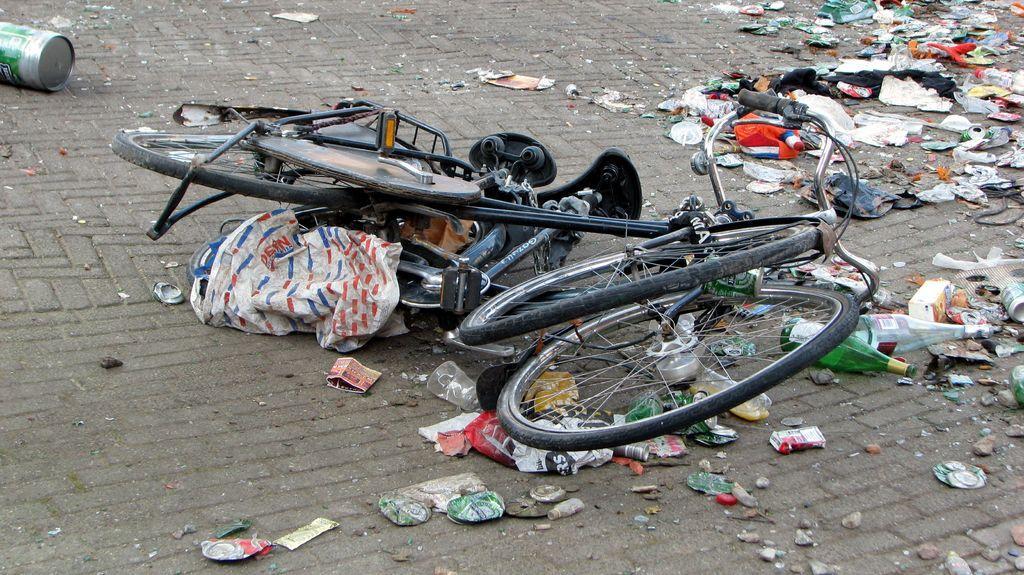Please provide a concise description of this image. In this image we can see a bicycle and also the scrap on the surface. 